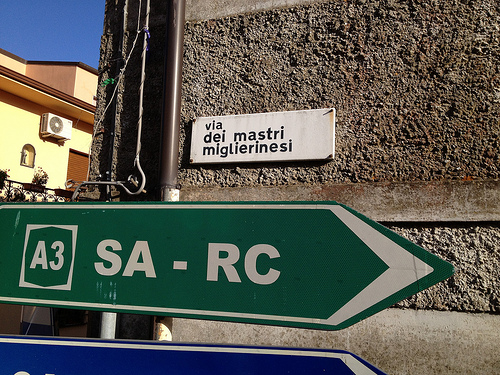What are the directions indicated on the road sign? The green road sign indicates directions for the A3 motorway, pointing towards SA (Salerno) on the left and RC (Reggio Calabria) on the right. 